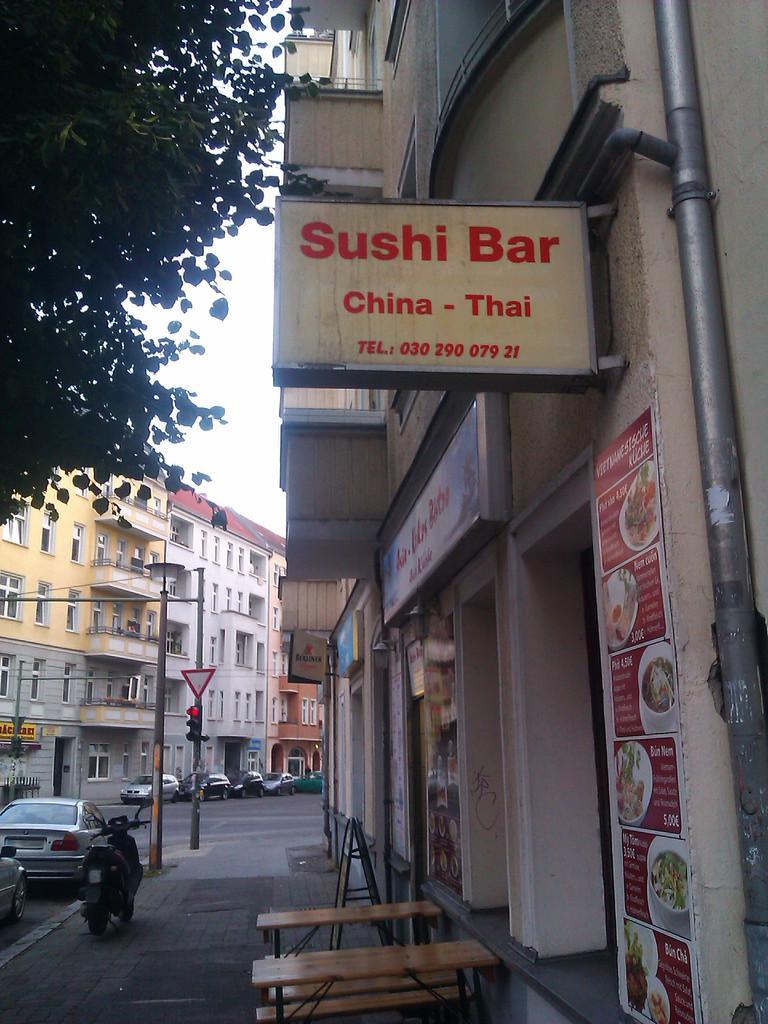Please provide a concise description of this image. In this picture we can see foot path and on footpath we have bike, pole, benches beside to this cars on road, building with windows, sign board, traffic signal, sky, pipe, name board. 